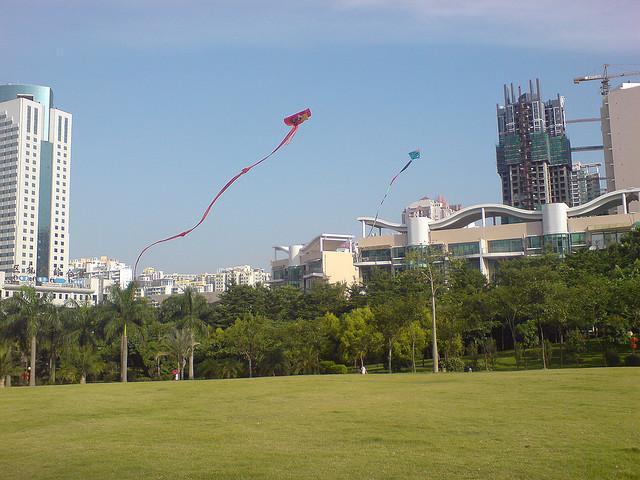How many cats have gray on their fur?
Give a very brief answer. 0. 